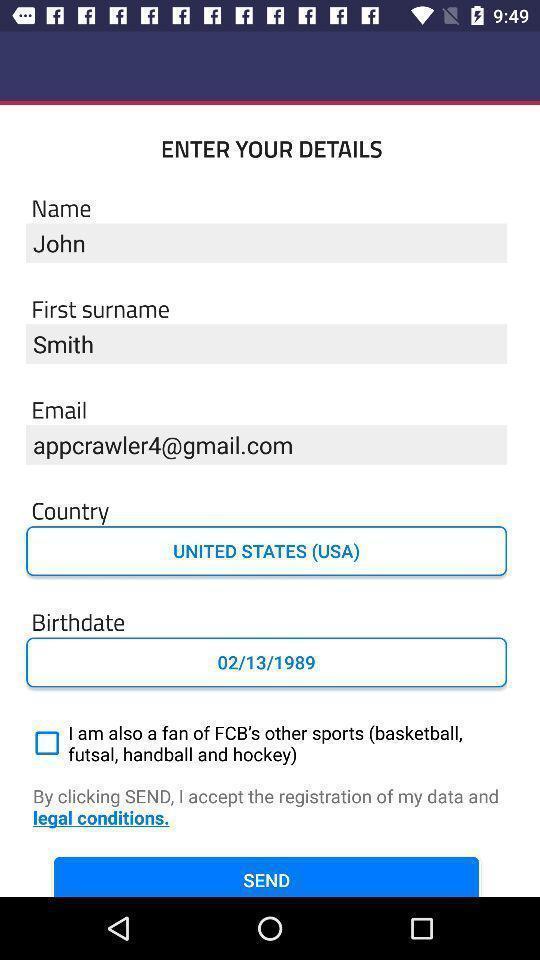Describe this image in words. Starting page with input details of a sports news app. 